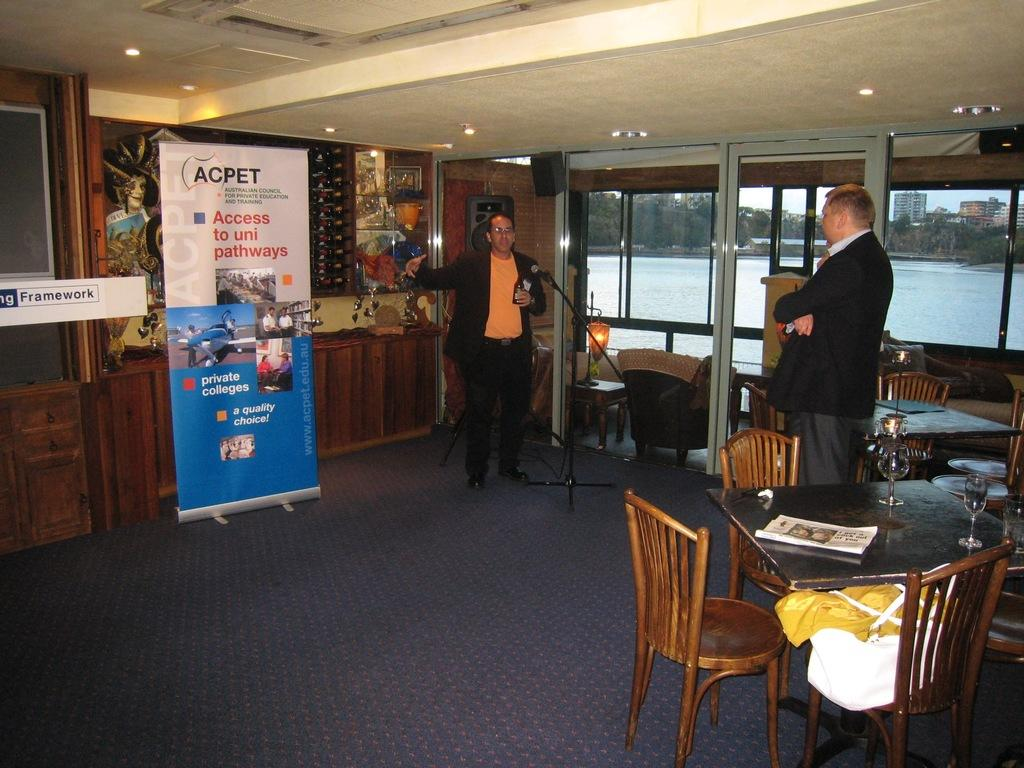What is the main setting of the image? There is a room in the image. How many people are present in the room? There are two persons standing in the room. What furniture is present in the room? There is a table in the room. What items are on the table? There is a glass and a paper on the table. What can be seen in the background of the image? The background of the image includes a sea, trees, and buildings. What type of engine can be seen in the image? There is no engine present in the image. How many dimes are visible on the table in the image? There are no dimes visible on the table in the image. 